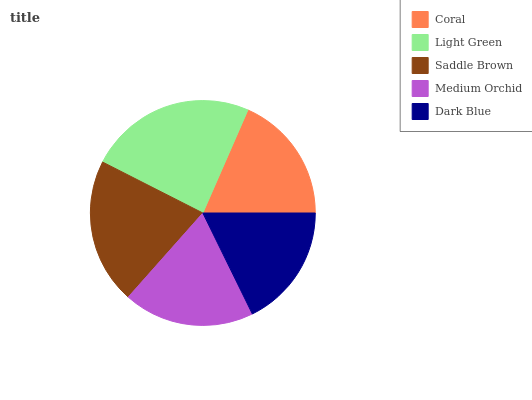Is Dark Blue the minimum?
Answer yes or no. Yes. Is Light Green the maximum?
Answer yes or no. Yes. Is Saddle Brown the minimum?
Answer yes or no. No. Is Saddle Brown the maximum?
Answer yes or no. No. Is Light Green greater than Saddle Brown?
Answer yes or no. Yes. Is Saddle Brown less than Light Green?
Answer yes or no. Yes. Is Saddle Brown greater than Light Green?
Answer yes or no. No. Is Light Green less than Saddle Brown?
Answer yes or no. No. Is Medium Orchid the high median?
Answer yes or no. Yes. Is Medium Orchid the low median?
Answer yes or no. Yes. Is Coral the high median?
Answer yes or no. No. Is Coral the low median?
Answer yes or no. No. 